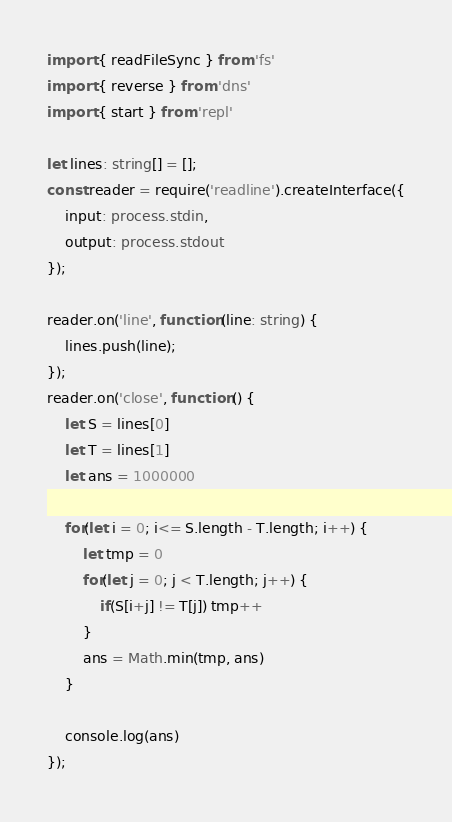Convert code to text. <code><loc_0><loc_0><loc_500><loc_500><_TypeScript_>import { readFileSync } from 'fs'
import { reverse } from 'dns'
import { start } from 'repl'
 
let lines: string[] = [];
const reader = require('readline').createInterface({
    input: process.stdin,
    output: process.stdout
});
 
reader.on('line', function (line: string) {
    lines.push(line);
});
reader.on('close', function () {
    let S = lines[0]
    let T = lines[1]
    let ans = 1000000

    for(let i = 0; i<= S.length - T.length; i++) {
        let tmp = 0
        for(let j = 0; j < T.length; j++) {
            if(S[i+j] != T[j]) tmp++
        }
        ans = Math.min(tmp, ans)
    }

    console.log(ans)
});</code> 